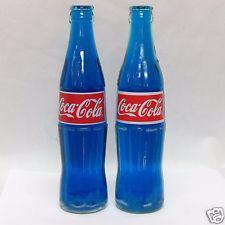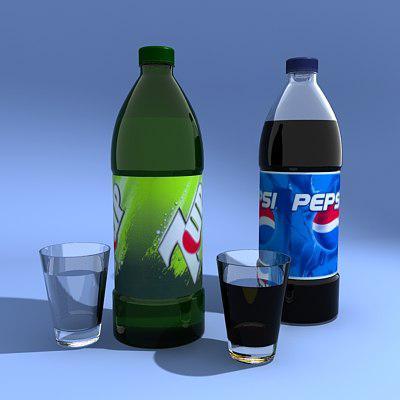The first image is the image on the left, the second image is the image on the right. Assess this claim about the two images: "There are two glass full of the liquad from the soda bottle behind them.". Correct or not? Answer yes or no. Yes. The first image is the image on the left, the second image is the image on the right. For the images displayed, is the sentence "In the left image there are exactly two bottles with soda in them." factually correct? Answer yes or no. No. 